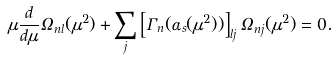Convert formula to latex. <formula><loc_0><loc_0><loc_500><loc_500>\mu \frac { d } { d \mu } \Omega _ { n l } ( \mu ^ { 2 } ) + \sum _ { j } \left [ \Gamma _ { n } ( \alpha _ { s } ( \mu ^ { 2 } ) ) \right ] _ { l j } \Omega _ { n j } ( \mu ^ { 2 } ) = 0 .</formula> 